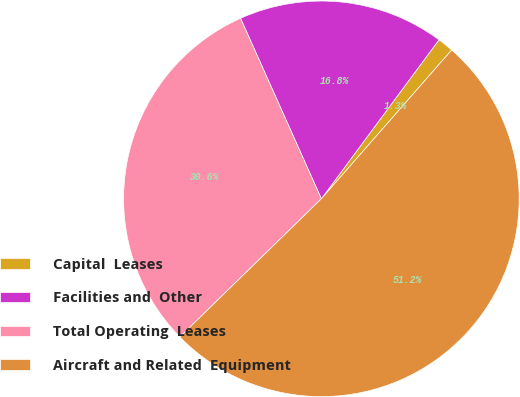Convert chart to OTSL. <chart><loc_0><loc_0><loc_500><loc_500><pie_chart><fcel>Capital  Leases<fcel>Facilities and  Other<fcel>Total Operating  Leases<fcel>Aircraft and Related  Equipment<nl><fcel>1.31%<fcel>16.84%<fcel>30.61%<fcel>51.24%<nl></chart> 